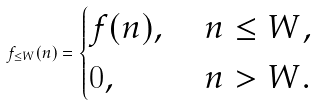<formula> <loc_0><loc_0><loc_500><loc_500>f _ { \leq W } ( n ) = \begin{cases} f ( n ) , \ & n \leq W , \\ 0 , & n > W . \end{cases}</formula> 